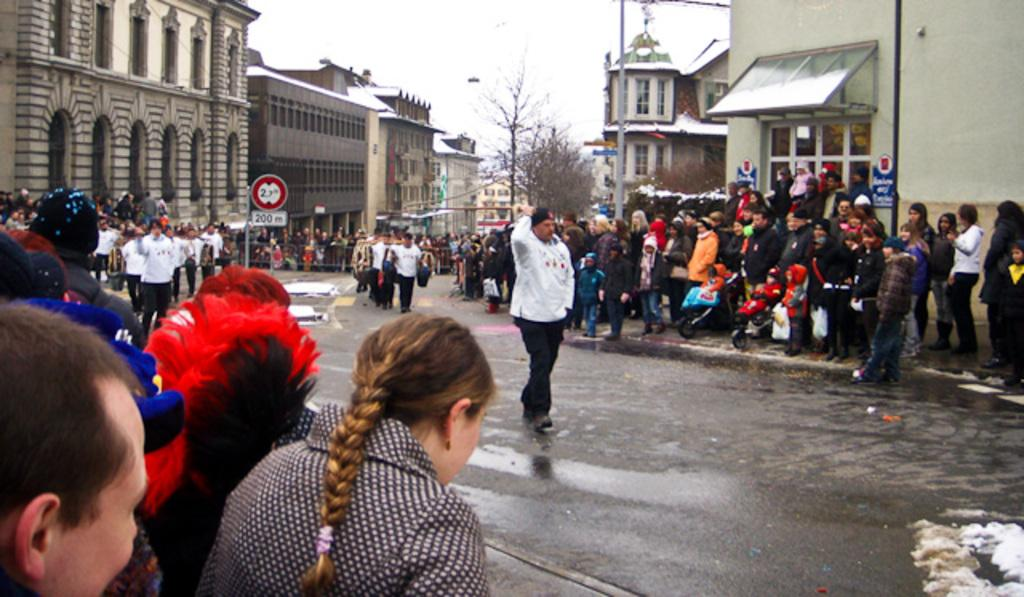How many people are present in the image? There are people in the image, but the exact number cannot be determined from the provided facts. What type of structures can be seen in the image? There are buildings in the image. What type of vegetation is present in the image? There are trees in the image. What type of vertical structures can be seen in the image? There are poles in the image. What type of flat structures can be seen in the image? There are boards in the image. What type of barrier can be seen in the image? There is a fence in the image. What type of surface is visible in the image? There is ground visible in the image. What part of the natural environment is visible in the image? The sky is visible in the image. What type of notebook is being used by the committee in the image? There is no mention of a notebook or committee in the image, so this question cannot be answered definitively. 